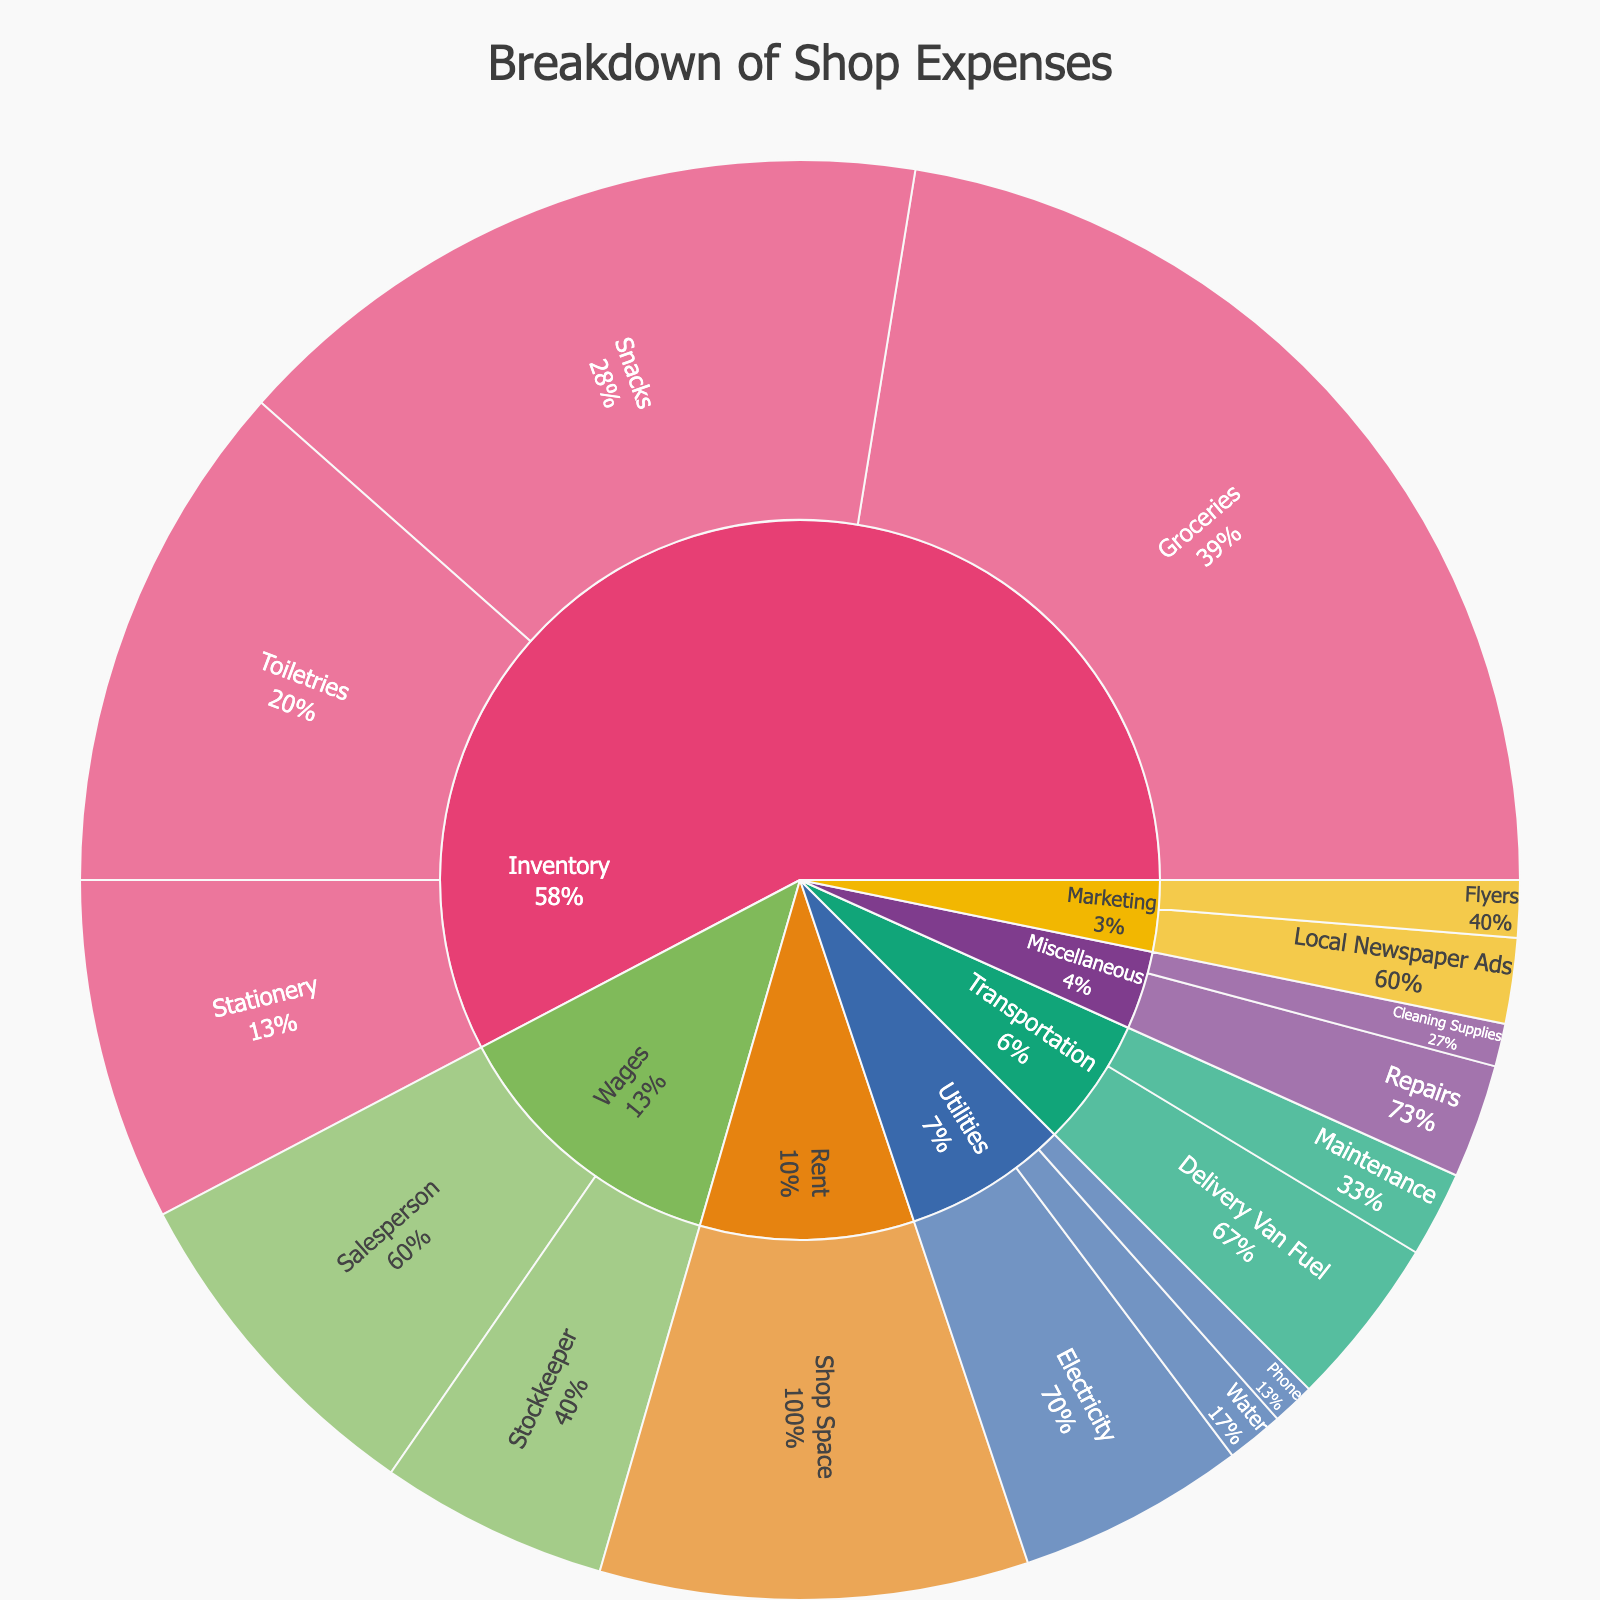What is the title of the Sunburst Plot? The title of the Sunburst Plot is usually displayed at the top of the figure, making it easily noticeable.
Answer: Breakdown of Shop Expenses Which category has the highest expense? By looking at the overall size of the segments, the category with the largest combined segment is the one with the highest expense.
Answer: Inventory What is the total expense on Marketing? To find the total expense on Marketing, add up the values for "Flyers" and "Local Newspaper Ads". That is ₹2,000 + ₹3,000.
Answer: ₹5,000 Which subcategory in Inventory has the largest expense? By observing the relative sizes of the subcategories within Inventory, the largest segment corresponds to the highest expense.
Answer: Groceries How much more is spent on Wages than on Rent? Compare the values for Wages and Rent. Wages total is ₹12,000 (Salesperson) + ₹8,000 (Stockkeeper), and Rent is ₹15,000. The difference is ₹20,000 - ₹15,000.
Answer: ₹5,000 Which category contributes the smallest percentage to the total expenses? Look for the smallest segment in the outermost ring. This category has the least contribution.
Answer: Miscellaneous What is the combined expense on Utilities? Sum the expenses on Electricity, Water, and Phone. That is ₹8,000 + ₹2,000 + ₹1,500.
Answer: ₹11,500 Which subcategory has the second highest expense in Transportation? By observing the two subcategories under Transportation, rank them by size and identify the second largest.
Answer: Maintenance Which category has the largest average subcategory expense? For each category, calculate the average expense per subcategory: sum up the subcategory expenses and divide by the number of subcategories. Compare these averages.
Answer: Inventory (₹22,500) What percentage of the total expenses is spent on the subcategory 'Salesperson'? Calculate the percentage by dividing the expense for Salesperson (₹12,000) by the total expenses, and multiply by 100.
Total expenses = sum of all categories and subcategories = ₹1,35,000.
So, (₹12,000 / ₹1,35,000) * 100.
Answer: 8.9% 